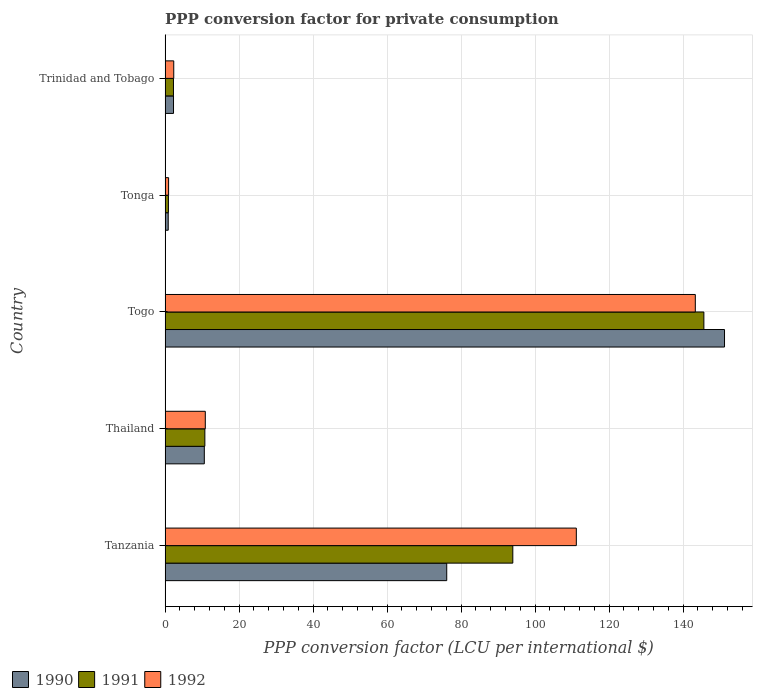How many groups of bars are there?
Your response must be concise. 5. What is the label of the 4th group of bars from the top?
Ensure brevity in your answer.  Thailand. What is the PPP conversion factor for private consumption in 1990 in Trinidad and Tobago?
Your response must be concise. 2.27. Across all countries, what is the maximum PPP conversion factor for private consumption in 1991?
Provide a short and direct response. 145.61. Across all countries, what is the minimum PPP conversion factor for private consumption in 1991?
Your answer should be very brief. 0.9. In which country was the PPP conversion factor for private consumption in 1992 maximum?
Offer a very short reply. Togo. In which country was the PPP conversion factor for private consumption in 1991 minimum?
Offer a very short reply. Tonga. What is the total PPP conversion factor for private consumption in 1992 in the graph?
Provide a succinct answer. 268.58. What is the difference between the PPP conversion factor for private consumption in 1992 in Thailand and that in Tonga?
Ensure brevity in your answer.  9.92. What is the difference between the PPP conversion factor for private consumption in 1991 in Togo and the PPP conversion factor for private consumption in 1990 in Tanzania?
Your answer should be very brief. 69.49. What is the average PPP conversion factor for private consumption in 1992 per country?
Give a very brief answer. 53.72. What is the difference between the PPP conversion factor for private consumption in 1990 and PPP conversion factor for private consumption in 1992 in Tanzania?
Offer a terse response. -35.03. What is the ratio of the PPP conversion factor for private consumption in 1990 in Tanzania to that in Togo?
Offer a terse response. 0.5. Is the PPP conversion factor for private consumption in 1991 in Tanzania less than that in Trinidad and Tobago?
Your answer should be very brief. No. Is the difference between the PPP conversion factor for private consumption in 1990 in Thailand and Togo greater than the difference between the PPP conversion factor for private consumption in 1992 in Thailand and Togo?
Give a very brief answer. No. What is the difference between the highest and the second highest PPP conversion factor for private consumption in 1990?
Keep it short and to the point. 75.08. What is the difference between the highest and the lowest PPP conversion factor for private consumption in 1992?
Your response must be concise. 142.35. In how many countries, is the PPP conversion factor for private consumption in 1990 greater than the average PPP conversion factor for private consumption in 1990 taken over all countries?
Provide a short and direct response. 2. What does the 3rd bar from the top in Trinidad and Tobago represents?
Offer a very short reply. 1990. Is it the case that in every country, the sum of the PPP conversion factor for private consumption in 1992 and PPP conversion factor for private consumption in 1991 is greater than the PPP conversion factor for private consumption in 1990?
Make the answer very short. Yes. How many bars are there?
Give a very brief answer. 15. Are all the bars in the graph horizontal?
Ensure brevity in your answer.  Yes. Does the graph contain any zero values?
Your answer should be compact. No. How are the legend labels stacked?
Provide a short and direct response. Horizontal. What is the title of the graph?
Provide a succinct answer. PPP conversion factor for private consumption. What is the label or title of the X-axis?
Make the answer very short. PPP conversion factor (LCU per international $). What is the PPP conversion factor (LCU per international $) of 1990 in Tanzania?
Provide a short and direct response. 76.11. What is the PPP conversion factor (LCU per international $) of 1991 in Tanzania?
Offer a terse response. 93.97. What is the PPP conversion factor (LCU per international $) of 1992 in Tanzania?
Ensure brevity in your answer.  111.14. What is the PPP conversion factor (LCU per international $) of 1990 in Thailand?
Offer a very short reply. 10.6. What is the PPP conversion factor (LCU per international $) in 1991 in Thailand?
Ensure brevity in your answer.  10.75. What is the PPP conversion factor (LCU per international $) in 1992 in Thailand?
Keep it short and to the point. 10.86. What is the PPP conversion factor (LCU per international $) in 1990 in Togo?
Make the answer very short. 151.19. What is the PPP conversion factor (LCU per international $) in 1991 in Togo?
Make the answer very short. 145.61. What is the PPP conversion factor (LCU per international $) in 1992 in Togo?
Give a very brief answer. 143.3. What is the PPP conversion factor (LCU per international $) in 1990 in Tonga?
Offer a very short reply. 0.85. What is the PPP conversion factor (LCU per international $) of 1991 in Tonga?
Your response must be concise. 0.9. What is the PPP conversion factor (LCU per international $) of 1992 in Tonga?
Provide a succinct answer. 0.94. What is the PPP conversion factor (LCU per international $) of 1990 in Trinidad and Tobago?
Ensure brevity in your answer.  2.27. What is the PPP conversion factor (LCU per international $) in 1991 in Trinidad and Tobago?
Your answer should be compact. 2.26. What is the PPP conversion factor (LCU per international $) in 1992 in Trinidad and Tobago?
Make the answer very short. 2.34. Across all countries, what is the maximum PPP conversion factor (LCU per international $) in 1990?
Give a very brief answer. 151.19. Across all countries, what is the maximum PPP conversion factor (LCU per international $) of 1991?
Your answer should be compact. 145.61. Across all countries, what is the maximum PPP conversion factor (LCU per international $) in 1992?
Offer a terse response. 143.3. Across all countries, what is the minimum PPP conversion factor (LCU per international $) in 1990?
Ensure brevity in your answer.  0.85. Across all countries, what is the minimum PPP conversion factor (LCU per international $) in 1991?
Offer a terse response. 0.9. Across all countries, what is the minimum PPP conversion factor (LCU per international $) of 1992?
Offer a very short reply. 0.94. What is the total PPP conversion factor (LCU per international $) in 1990 in the graph?
Offer a very short reply. 241.02. What is the total PPP conversion factor (LCU per international $) in 1991 in the graph?
Make the answer very short. 253.5. What is the total PPP conversion factor (LCU per international $) of 1992 in the graph?
Offer a very short reply. 268.58. What is the difference between the PPP conversion factor (LCU per international $) of 1990 in Tanzania and that in Thailand?
Your answer should be compact. 65.52. What is the difference between the PPP conversion factor (LCU per international $) in 1991 in Tanzania and that in Thailand?
Your response must be concise. 83.23. What is the difference between the PPP conversion factor (LCU per international $) in 1992 in Tanzania and that in Thailand?
Offer a very short reply. 100.28. What is the difference between the PPP conversion factor (LCU per international $) of 1990 in Tanzania and that in Togo?
Provide a short and direct response. -75.08. What is the difference between the PPP conversion factor (LCU per international $) of 1991 in Tanzania and that in Togo?
Your answer should be very brief. -51.63. What is the difference between the PPP conversion factor (LCU per international $) in 1992 in Tanzania and that in Togo?
Provide a succinct answer. -32.16. What is the difference between the PPP conversion factor (LCU per international $) of 1990 in Tanzania and that in Tonga?
Your answer should be very brief. 75.26. What is the difference between the PPP conversion factor (LCU per international $) in 1991 in Tanzania and that in Tonga?
Keep it short and to the point. 93.07. What is the difference between the PPP conversion factor (LCU per international $) in 1992 in Tanzania and that in Tonga?
Your answer should be very brief. 110.19. What is the difference between the PPP conversion factor (LCU per international $) of 1990 in Tanzania and that in Trinidad and Tobago?
Your answer should be compact. 73.84. What is the difference between the PPP conversion factor (LCU per international $) of 1991 in Tanzania and that in Trinidad and Tobago?
Offer a terse response. 91.71. What is the difference between the PPP conversion factor (LCU per international $) in 1992 in Tanzania and that in Trinidad and Tobago?
Offer a very short reply. 108.8. What is the difference between the PPP conversion factor (LCU per international $) of 1990 in Thailand and that in Togo?
Provide a succinct answer. -140.59. What is the difference between the PPP conversion factor (LCU per international $) of 1991 in Thailand and that in Togo?
Keep it short and to the point. -134.86. What is the difference between the PPP conversion factor (LCU per international $) of 1992 in Thailand and that in Togo?
Your answer should be very brief. -132.43. What is the difference between the PPP conversion factor (LCU per international $) in 1990 in Thailand and that in Tonga?
Give a very brief answer. 9.75. What is the difference between the PPP conversion factor (LCU per international $) of 1991 in Thailand and that in Tonga?
Give a very brief answer. 9.85. What is the difference between the PPP conversion factor (LCU per international $) in 1992 in Thailand and that in Tonga?
Provide a succinct answer. 9.92. What is the difference between the PPP conversion factor (LCU per international $) of 1990 in Thailand and that in Trinidad and Tobago?
Offer a very short reply. 8.32. What is the difference between the PPP conversion factor (LCU per international $) of 1991 in Thailand and that in Trinidad and Tobago?
Ensure brevity in your answer.  8.48. What is the difference between the PPP conversion factor (LCU per international $) in 1992 in Thailand and that in Trinidad and Tobago?
Make the answer very short. 8.52. What is the difference between the PPP conversion factor (LCU per international $) of 1990 in Togo and that in Tonga?
Give a very brief answer. 150.34. What is the difference between the PPP conversion factor (LCU per international $) of 1991 in Togo and that in Tonga?
Provide a succinct answer. 144.71. What is the difference between the PPP conversion factor (LCU per international $) of 1992 in Togo and that in Tonga?
Your answer should be very brief. 142.35. What is the difference between the PPP conversion factor (LCU per international $) of 1990 in Togo and that in Trinidad and Tobago?
Make the answer very short. 148.91. What is the difference between the PPP conversion factor (LCU per international $) in 1991 in Togo and that in Trinidad and Tobago?
Offer a terse response. 143.34. What is the difference between the PPP conversion factor (LCU per international $) in 1992 in Togo and that in Trinidad and Tobago?
Offer a very short reply. 140.96. What is the difference between the PPP conversion factor (LCU per international $) in 1990 in Tonga and that in Trinidad and Tobago?
Provide a short and direct response. -1.42. What is the difference between the PPP conversion factor (LCU per international $) of 1991 in Tonga and that in Trinidad and Tobago?
Your response must be concise. -1.36. What is the difference between the PPP conversion factor (LCU per international $) in 1992 in Tonga and that in Trinidad and Tobago?
Make the answer very short. -1.39. What is the difference between the PPP conversion factor (LCU per international $) in 1990 in Tanzania and the PPP conversion factor (LCU per international $) in 1991 in Thailand?
Your answer should be very brief. 65.37. What is the difference between the PPP conversion factor (LCU per international $) of 1990 in Tanzania and the PPP conversion factor (LCU per international $) of 1992 in Thailand?
Keep it short and to the point. 65.25. What is the difference between the PPP conversion factor (LCU per international $) of 1991 in Tanzania and the PPP conversion factor (LCU per international $) of 1992 in Thailand?
Make the answer very short. 83.11. What is the difference between the PPP conversion factor (LCU per international $) of 1990 in Tanzania and the PPP conversion factor (LCU per international $) of 1991 in Togo?
Keep it short and to the point. -69.49. What is the difference between the PPP conversion factor (LCU per international $) of 1990 in Tanzania and the PPP conversion factor (LCU per international $) of 1992 in Togo?
Your answer should be very brief. -67.18. What is the difference between the PPP conversion factor (LCU per international $) of 1991 in Tanzania and the PPP conversion factor (LCU per international $) of 1992 in Togo?
Provide a short and direct response. -49.32. What is the difference between the PPP conversion factor (LCU per international $) in 1990 in Tanzania and the PPP conversion factor (LCU per international $) in 1991 in Tonga?
Your response must be concise. 75.21. What is the difference between the PPP conversion factor (LCU per international $) of 1990 in Tanzania and the PPP conversion factor (LCU per international $) of 1992 in Tonga?
Offer a very short reply. 75.17. What is the difference between the PPP conversion factor (LCU per international $) in 1991 in Tanzania and the PPP conversion factor (LCU per international $) in 1992 in Tonga?
Your answer should be very brief. 93.03. What is the difference between the PPP conversion factor (LCU per international $) of 1990 in Tanzania and the PPP conversion factor (LCU per international $) of 1991 in Trinidad and Tobago?
Offer a very short reply. 73.85. What is the difference between the PPP conversion factor (LCU per international $) of 1990 in Tanzania and the PPP conversion factor (LCU per international $) of 1992 in Trinidad and Tobago?
Make the answer very short. 73.77. What is the difference between the PPP conversion factor (LCU per international $) in 1991 in Tanzania and the PPP conversion factor (LCU per international $) in 1992 in Trinidad and Tobago?
Keep it short and to the point. 91.64. What is the difference between the PPP conversion factor (LCU per international $) of 1990 in Thailand and the PPP conversion factor (LCU per international $) of 1991 in Togo?
Your answer should be very brief. -135.01. What is the difference between the PPP conversion factor (LCU per international $) in 1990 in Thailand and the PPP conversion factor (LCU per international $) in 1992 in Togo?
Provide a succinct answer. -132.7. What is the difference between the PPP conversion factor (LCU per international $) in 1991 in Thailand and the PPP conversion factor (LCU per international $) in 1992 in Togo?
Offer a very short reply. -132.55. What is the difference between the PPP conversion factor (LCU per international $) in 1990 in Thailand and the PPP conversion factor (LCU per international $) in 1991 in Tonga?
Keep it short and to the point. 9.7. What is the difference between the PPP conversion factor (LCU per international $) in 1990 in Thailand and the PPP conversion factor (LCU per international $) in 1992 in Tonga?
Offer a terse response. 9.65. What is the difference between the PPP conversion factor (LCU per international $) of 1991 in Thailand and the PPP conversion factor (LCU per international $) of 1992 in Tonga?
Ensure brevity in your answer.  9.8. What is the difference between the PPP conversion factor (LCU per international $) in 1990 in Thailand and the PPP conversion factor (LCU per international $) in 1991 in Trinidad and Tobago?
Offer a terse response. 8.33. What is the difference between the PPP conversion factor (LCU per international $) of 1990 in Thailand and the PPP conversion factor (LCU per international $) of 1992 in Trinidad and Tobago?
Offer a terse response. 8.26. What is the difference between the PPP conversion factor (LCU per international $) in 1991 in Thailand and the PPP conversion factor (LCU per international $) in 1992 in Trinidad and Tobago?
Your response must be concise. 8.41. What is the difference between the PPP conversion factor (LCU per international $) of 1990 in Togo and the PPP conversion factor (LCU per international $) of 1991 in Tonga?
Make the answer very short. 150.29. What is the difference between the PPP conversion factor (LCU per international $) in 1990 in Togo and the PPP conversion factor (LCU per international $) in 1992 in Tonga?
Offer a very short reply. 150.24. What is the difference between the PPP conversion factor (LCU per international $) in 1991 in Togo and the PPP conversion factor (LCU per international $) in 1992 in Tonga?
Keep it short and to the point. 144.66. What is the difference between the PPP conversion factor (LCU per international $) in 1990 in Togo and the PPP conversion factor (LCU per international $) in 1991 in Trinidad and Tobago?
Ensure brevity in your answer.  148.92. What is the difference between the PPP conversion factor (LCU per international $) in 1990 in Togo and the PPP conversion factor (LCU per international $) in 1992 in Trinidad and Tobago?
Make the answer very short. 148.85. What is the difference between the PPP conversion factor (LCU per international $) of 1991 in Togo and the PPP conversion factor (LCU per international $) of 1992 in Trinidad and Tobago?
Make the answer very short. 143.27. What is the difference between the PPP conversion factor (LCU per international $) of 1990 in Tonga and the PPP conversion factor (LCU per international $) of 1991 in Trinidad and Tobago?
Make the answer very short. -1.41. What is the difference between the PPP conversion factor (LCU per international $) of 1990 in Tonga and the PPP conversion factor (LCU per international $) of 1992 in Trinidad and Tobago?
Give a very brief answer. -1.49. What is the difference between the PPP conversion factor (LCU per international $) of 1991 in Tonga and the PPP conversion factor (LCU per international $) of 1992 in Trinidad and Tobago?
Give a very brief answer. -1.44. What is the average PPP conversion factor (LCU per international $) in 1990 per country?
Your answer should be compact. 48.2. What is the average PPP conversion factor (LCU per international $) of 1991 per country?
Offer a very short reply. 50.7. What is the average PPP conversion factor (LCU per international $) in 1992 per country?
Keep it short and to the point. 53.72. What is the difference between the PPP conversion factor (LCU per international $) in 1990 and PPP conversion factor (LCU per international $) in 1991 in Tanzania?
Your answer should be compact. -17.86. What is the difference between the PPP conversion factor (LCU per international $) in 1990 and PPP conversion factor (LCU per international $) in 1992 in Tanzania?
Provide a succinct answer. -35.03. What is the difference between the PPP conversion factor (LCU per international $) in 1991 and PPP conversion factor (LCU per international $) in 1992 in Tanzania?
Give a very brief answer. -17.16. What is the difference between the PPP conversion factor (LCU per international $) in 1990 and PPP conversion factor (LCU per international $) in 1991 in Thailand?
Your response must be concise. -0.15. What is the difference between the PPP conversion factor (LCU per international $) in 1990 and PPP conversion factor (LCU per international $) in 1992 in Thailand?
Make the answer very short. -0.27. What is the difference between the PPP conversion factor (LCU per international $) of 1991 and PPP conversion factor (LCU per international $) of 1992 in Thailand?
Keep it short and to the point. -0.12. What is the difference between the PPP conversion factor (LCU per international $) in 1990 and PPP conversion factor (LCU per international $) in 1991 in Togo?
Ensure brevity in your answer.  5.58. What is the difference between the PPP conversion factor (LCU per international $) in 1990 and PPP conversion factor (LCU per international $) in 1992 in Togo?
Provide a succinct answer. 7.89. What is the difference between the PPP conversion factor (LCU per international $) of 1991 and PPP conversion factor (LCU per international $) of 1992 in Togo?
Your answer should be compact. 2.31. What is the difference between the PPP conversion factor (LCU per international $) in 1990 and PPP conversion factor (LCU per international $) in 1991 in Tonga?
Offer a very short reply. -0.05. What is the difference between the PPP conversion factor (LCU per international $) in 1990 and PPP conversion factor (LCU per international $) in 1992 in Tonga?
Offer a terse response. -0.09. What is the difference between the PPP conversion factor (LCU per international $) in 1991 and PPP conversion factor (LCU per international $) in 1992 in Tonga?
Keep it short and to the point. -0.04. What is the difference between the PPP conversion factor (LCU per international $) in 1990 and PPP conversion factor (LCU per international $) in 1991 in Trinidad and Tobago?
Keep it short and to the point. 0.01. What is the difference between the PPP conversion factor (LCU per international $) of 1990 and PPP conversion factor (LCU per international $) of 1992 in Trinidad and Tobago?
Provide a short and direct response. -0.07. What is the difference between the PPP conversion factor (LCU per international $) in 1991 and PPP conversion factor (LCU per international $) in 1992 in Trinidad and Tobago?
Provide a succinct answer. -0.07. What is the ratio of the PPP conversion factor (LCU per international $) of 1990 in Tanzania to that in Thailand?
Offer a very short reply. 7.18. What is the ratio of the PPP conversion factor (LCU per international $) of 1991 in Tanzania to that in Thailand?
Provide a succinct answer. 8.74. What is the ratio of the PPP conversion factor (LCU per international $) in 1992 in Tanzania to that in Thailand?
Your response must be concise. 10.23. What is the ratio of the PPP conversion factor (LCU per international $) of 1990 in Tanzania to that in Togo?
Give a very brief answer. 0.5. What is the ratio of the PPP conversion factor (LCU per international $) in 1991 in Tanzania to that in Togo?
Offer a terse response. 0.65. What is the ratio of the PPP conversion factor (LCU per international $) of 1992 in Tanzania to that in Togo?
Ensure brevity in your answer.  0.78. What is the ratio of the PPP conversion factor (LCU per international $) of 1990 in Tanzania to that in Tonga?
Your answer should be compact. 89.58. What is the ratio of the PPP conversion factor (LCU per international $) in 1991 in Tanzania to that in Tonga?
Provide a short and direct response. 104.24. What is the ratio of the PPP conversion factor (LCU per international $) of 1992 in Tanzania to that in Tonga?
Offer a very short reply. 117.67. What is the ratio of the PPP conversion factor (LCU per international $) in 1990 in Tanzania to that in Trinidad and Tobago?
Offer a very short reply. 33.47. What is the ratio of the PPP conversion factor (LCU per international $) of 1991 in Tanzania to that in Trinidad and Tobago?
Your answer should be compact. 41.5. What is the ratio of the PPP conversion factor (LCU per international $) in 1992 in Tanzania to that in Trinidad and Tobago?
Offer a very short reply. 47.51. What is the ratio of the PPP conversion factor (LCU per international $) in 1990 in Thailand to that in Togo?
Keep it short and to the point. 0.07. What is the ratio of the PPP conversion factor (LCU per international $) in 1991 in Thailand to that in Togo?
Provide a short and direct response. 0.07. What is the ratio of the PPP conversion factor (LCU per international $) of 1992 in Thailand to that in Togo?
Offer a very short reply. 0.08. What is the ratio of the PPP conversion factor (LCU per international $) of 1990 in Thailand to that in Tonga?
Provide a succinct answer. 12.47. What is the ratio of the PPP conversion factor (LCU per international $) of 1991 in Thailand to that in Tonga?
Your answer should be very brief. 11.92. What is the ratio of the PPP conversion factor (LCU per international $) in 1992 in Thailand to that in Tonga?
Make the answer very short. 11.5. What is the ratio of the PPP conversion factor (LCU per international $) in 1990 in Thailand to that in Trinidad and Tobago?
Ensure brevity in your answer.  4.66. What is the ratio of the PPP conversion factor (LCU per international $) of 1991 in Thailand to that in Trinidad and Tobago?
Your answer should be very brief. 4.75. What is the ratio of the PPP conversion factor (LCU per international $) of 1992 in Thailand to that in Trinidad and Tobago?
Provide a short and direct response. 4.64. What is the ratio of the PPP conversion factor (LCU per international $) of 1990 in Togo to that in Tonga?
Make the answer very short. 177.93. What is the ratio of the PPP conversion factor (LCU per international $) in 1991 in Togo to that in Tonga?
Provide a succinct answer. 161.51. What is the ratio of the PPP conversion factor (LCU per international $) in 1992 in Togo to that in Tonga?
Make the answer very short. 151.72. What is the ratio of the PPP conversion factor (LCU per international $) of 1990 in Togo to that in Trinidad and Tobago?
Offer a very short reply. 66.48. What is the ratio of the PPP conversion factor (LCU per international $) in 1991 in Togo to that in Trinidad and Tobago?
Provide a short and direct response. 64.31. What is the ratio of the PPP conversion factor (LCU per international $) of 1992 in Togo to that in Trinidad and Tobago?
Provide a short and direct response. 61.26. What is the ratio of the PPP conversion factor (LCU per international $) in 1990 in Tonga to that in Trinidad and Tobago?
Provide a short and direct response. 0.37. What is the ratio of the PPP conversion factor (LCU per international $) of 1991 in Tonga to that in Trinidad and Tobago?
Your answer should be very brief. 0.4. What is the ratio of the PPP conversion factor (LCU per international $) of 1992 in Tonga to that in Trinidad and Tobago?
Ensure brevity in your answer.  0.4. What is the difference between the highest and the second highest PPP conversion factor (LCU per international $) in 1990?
Give a very brief answer. 75.08. What is the difference between the highest and the second highest PPP conversion factor (LCU per international $) of 1991?
Offer a very short reply. 51.63. What is the difference between the highest and the second highest PPP conversion factor (LCU per international $) of 1992?
Keep it short and to the point. 32.16. What is the difference between the highest and the lowest PPP conversion factor (LCU per international $) of 1990?
Make the answer very short. 150.34. What is the difference between the highest and the lowest PPP conversion factor (LCU per international $) of 1991?
Give a very brief answer. 144.71. What is the difference between the highest and the lowest PPP conversion factor (LCU per international $) of 1992?
Your answer should be very brief. 142.35. 